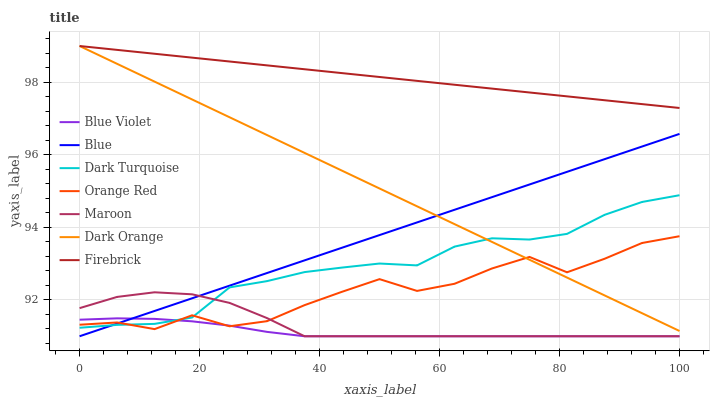Does Blue Violet have the minimum area under the curve?
Answer yes or no. Yes. Does Firebrick have the maximum area under the curve?
Answer yes or no. Yes. Does Dark Orange have the minimum area under the curve?
Answer yes or no. No. Does Dark Orange have the maximum area under the curve?
Answer yes or no. No. Is Blue the smoothest?
Answer yes or no. Yes. Is Orange Red the roughest?
Answer yes or no. Yes. Is Dark Turquoise the smoothest?
Answer yes or no. No. Is Dark Turquoise the roughest?
Answer yes or no. No. Does Blue have the lowest value?
Answer yes or no. Yes. Does Dark Orange have the lowest value?
Answer yes or no. No. Does Firebrick have the highest value?
Answer yes or no. Yes. Does Dark Turquoise have the highest value?
Answer yes or no. No. Is Blue less than Firebrick?
Answer yes or no. Yes. Is Dark Orange greater than Maroon?
Answer yes or no. Yes. Does Dark Turquoise intersect Orange Red?
Answer yes or no. Yes. Is Dark Turquoise less than Orange Red?
Answer yes or no. No. Is Dark Turquoise greater than Orange Red?
Answer yes or no. No. Does Blue intersect Firebrick?
Answer yes or no. No. 